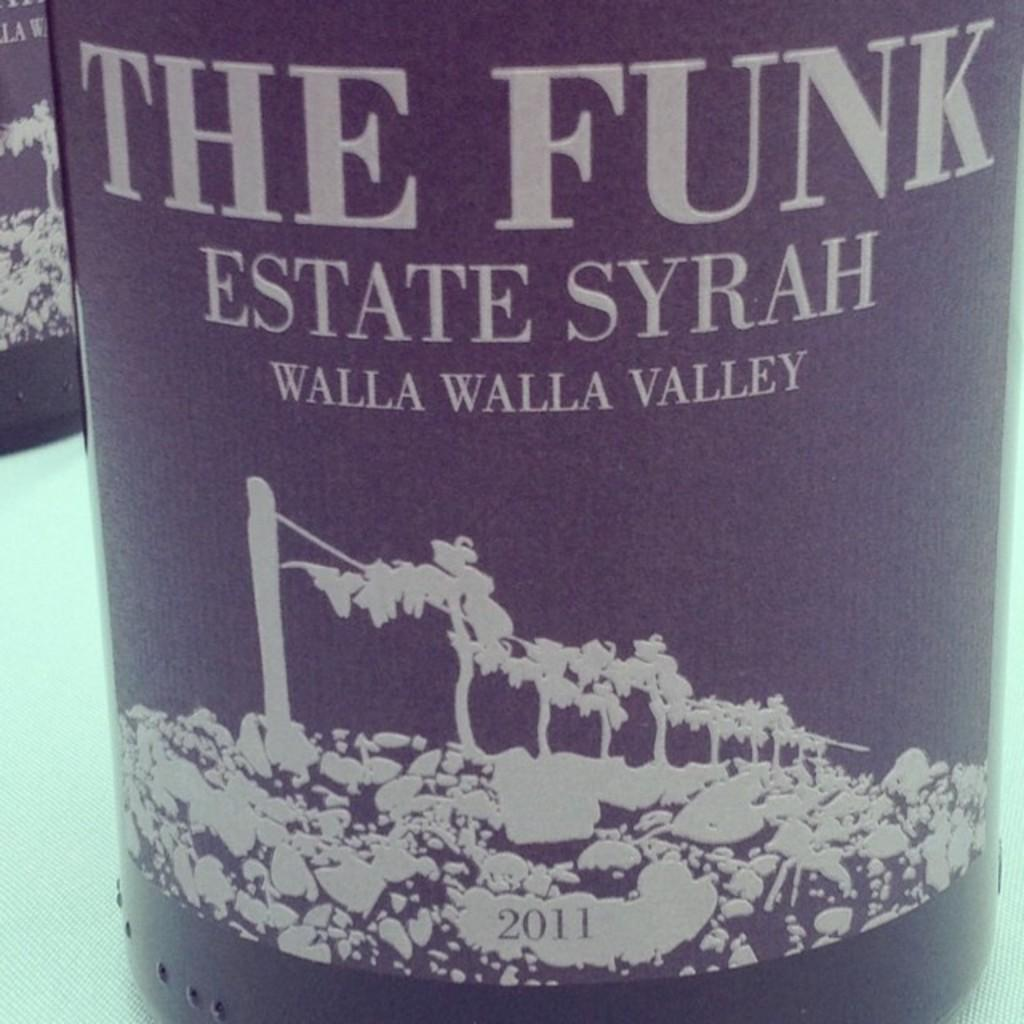<image>
Write a terse but informative summary of the picture. A bottle of The Funk Estate Syrah wine with a vineyard on the label. 